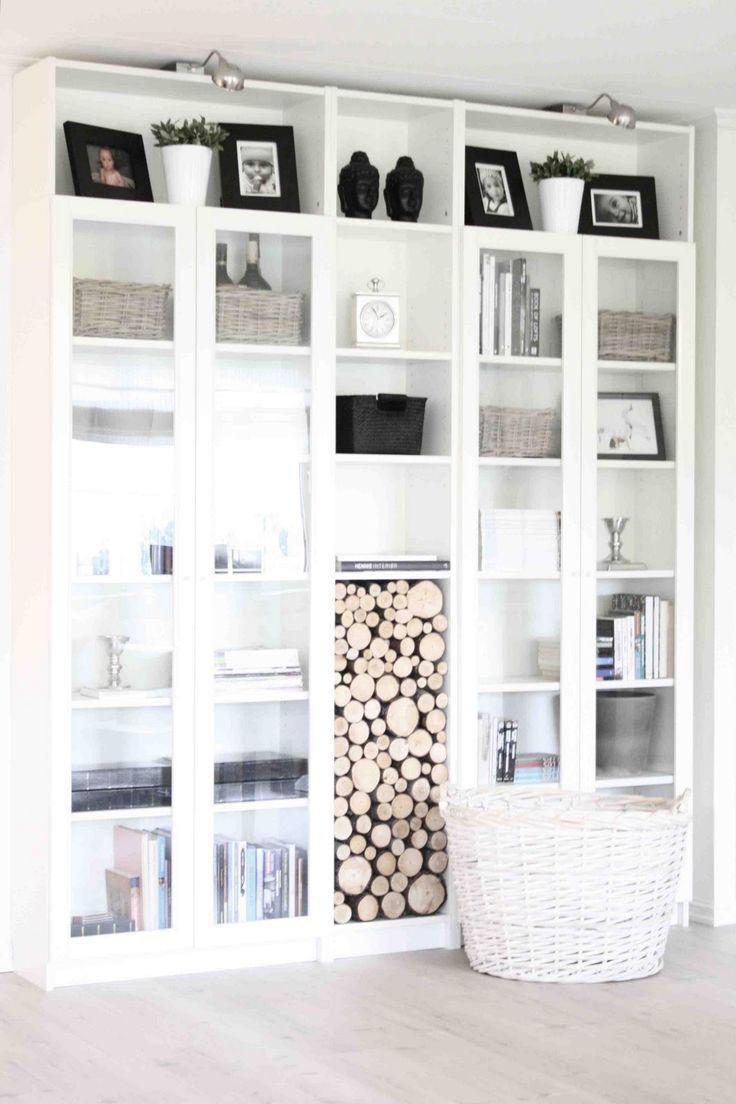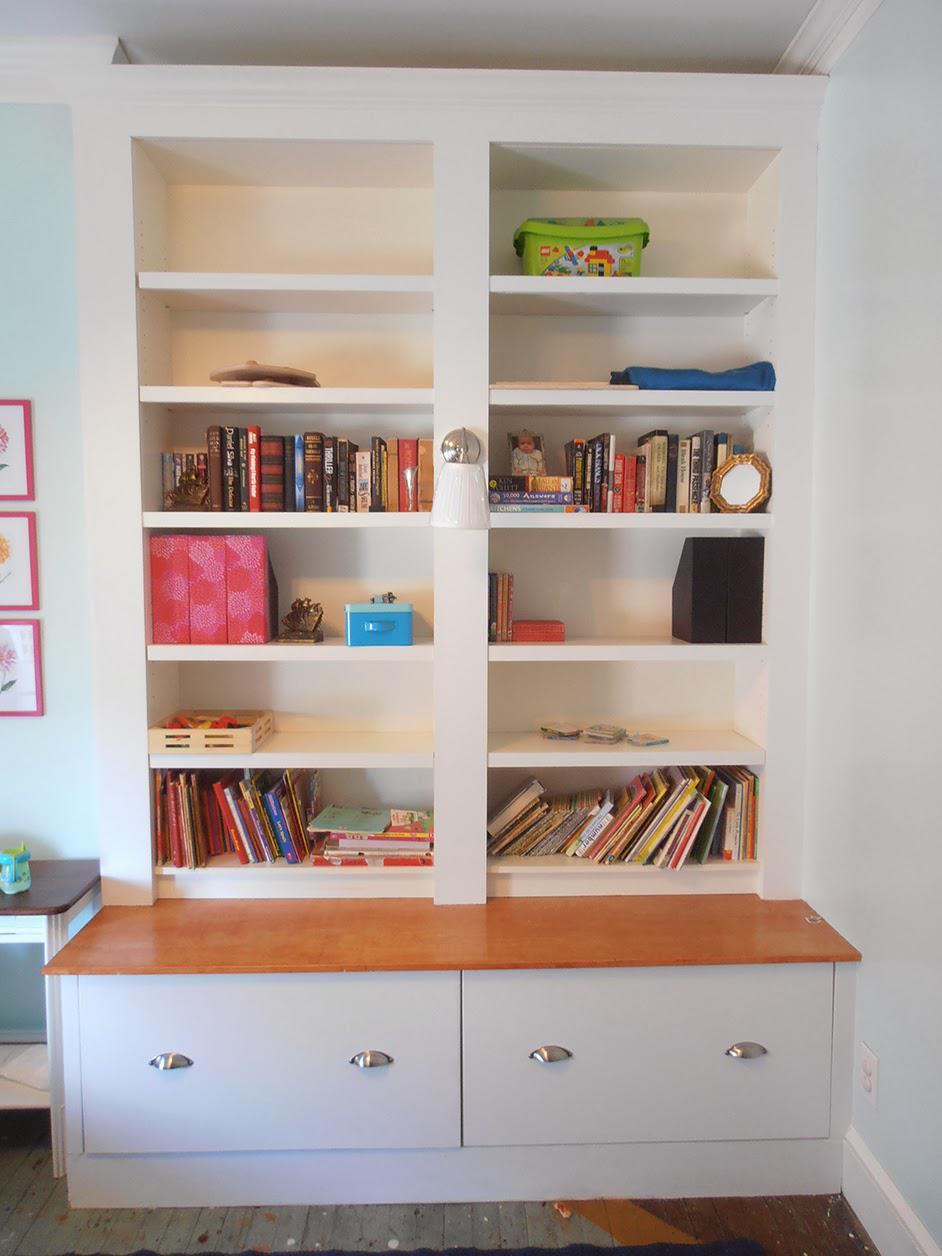The first image is the image on the left, the second image is the image on the right. Assess this claim about the two images: "In one image, a floor to ceiling white shelving unit is curved around the corner of a room.". Correct or not? Answer yes or no. No. 